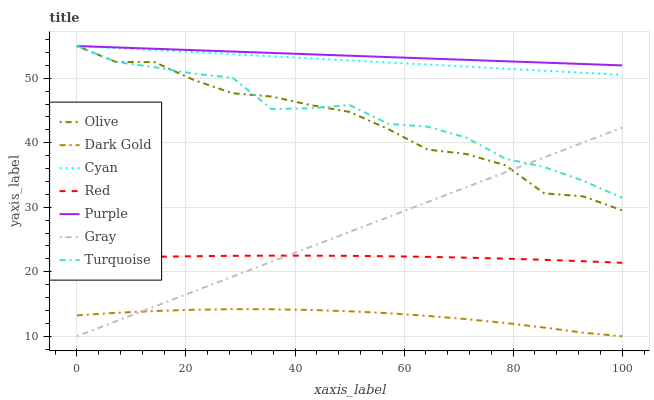Does Dark Gold have the minimum area under the curve?
Answer yes or no. Yes. Does Purple have the maximum area under the curve?
Answer yes or no. Yes. Does Turquoise have the minimum area under the curve?
Answer yes or no. No. Does Turquoise have the maximum area under the curve?
Answer yes or no. No. Is Gray the smoothest?
Answer yes or no. Yes. Is Turquoise the roughest?
Answer yes or no. Yes. Is Dark Gold the smoothest?
Answer yes or no. No. Is Dark Gold the roughest?
Answer yes or no. No. Does Gray have the lowest value?
Answer yes or no. Yes. Does Turquoise have the lowest value?
Answer yes or no. No. Does Cyan have the highest value?
Answer yes or no. Yes. Does Dark Gold have the highest value?
Answer yes or no. No. Is Dark Gold less than Olive?
Answer yes or no. Yes. Is Cyan greater than Red?
Answer yes or no. Yes. Does Dark Gold intersect Gray?
Answer yes or no. Yes. Is Dark Gold less than Gray?
Answer yes or no. No. Is Dark Gold greater than Gray?
Answer yes or no. No. Does Dark Gold intersect Olive?
Answer yes or no. No. 